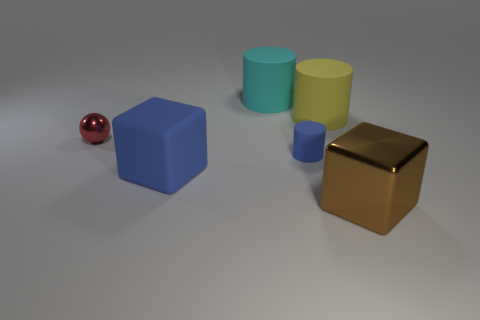What shape is the yellow thing right of the small thing to the left of the large rubber cylinder that is behind the big yellow cylinder?
Provide a succinct answer. Cylinder. The big thing that is behind the large metal cube and in front of the big yellow cylinder is what color?
Make the answer very short. Blue. What is the shape of the metal thing that is on the right side of the small red sphere?
Offer a very short reply. Cube. The small red object that is the same material as the brown thing is what shape?
Your answer should be very brief. Sphere. What number of shiny objects are blue blocks or cubes?
Offer a very short reply. 1. How many big brown cubes are left of the large cube left of the large cube in front of the big rubber cube?
Offer a terse response. 0. Does the cylinder that is in front of the large yellow rubber thing have the same size as the shiny thing that is to the right of the blue matte block?
Ensure brevity in your answer.  No. There is a blue thing that is the same shape as the cyan thing; what is it made of?
Ensure brevity in your answer.  Rubber. How many small objects are yellow rubber cylinders or brown metallic things?
Your response must be concise. 0. What material is the big yellow cylinder?
Keep it short and to the point. Rubber. 